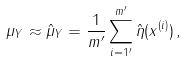<formula> <loc_0><loc_0><loc_500><loc_500>\mu _ { Y } \approx \hat { \mu } _ { Y } = \frac { 1 } { m ^ { \prime } } \sum _ { i = 1 ^ { \prime } } ^ { m ^ { \prime } } \hat { \eta } ( x ^ { ( i ) } ) \, ,</formula> 